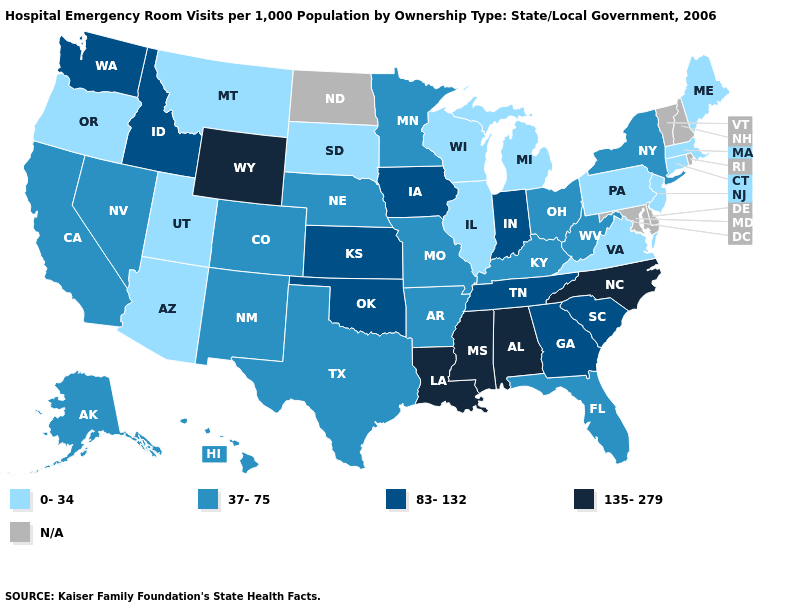What is the value of Pennsylvania?
Be succinct. 0-34. Which states hav the highest value in the MidWest?
Write a very short answer. Indiana, Iowa, Kansas. What is the highest value in the West ?
Keep it brief. 135-279. Among the states that border Connecticut , which have the lowest value?
Concise answer only. Massachusetts. Name the states that have a value in the range 135-279?
Give a very brief answer. Alabama, Louisiana, Mississippi, North Carolina, Wyoming. What is the value of Wyoming?
Concise answer only. 135-279. Name the states that have a value in the range 135-279?
Keep it brief. Alabama, Louisiana, Mississippi, North Carolina, Wyoming. What is the value of Minnesota?
Write a very short answer. 37-75. What is the value of California?
Give a very brief answer. 37-75. Which states have the lowest value in the West?
Short answer required. Arizona, Montana, Oregon, Utah. Which states have the highest value in the USA?
Be succinct. Alabama, Louisiana, Mississippi, North Carolina, Wyoming. Among the states that border Virginia , does West Virginia have the lowest value?
Write a very short answer. Yes. 